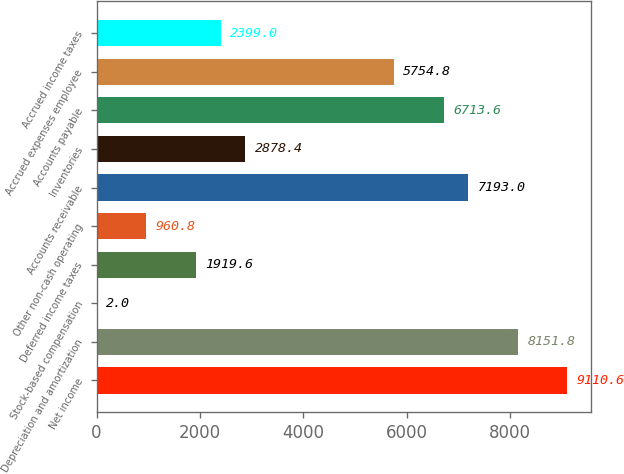<chart> <loc_0><loc_0><loc_500><loc_500><bar_chart><fcel>Net income<fcel>Depreciation and amortization<fcel>Stock-based compensation<fcel>Deferred income taxes<fcel>Other non-cash operating<fcel>Accounts receivable<fcel>Inventories<fcel>Accounts payable<fcel>Accrued expenses employee<fcel>Accrued income taxes<nl><fcel>9110.6<fcel>8151.8<fcel>2<fcel>1919.6<fcel>960.8<fcel>7193<fcel>2878.4<fcel>6713.6<fcel>5754.8<fcel>2399<nl></chart> 